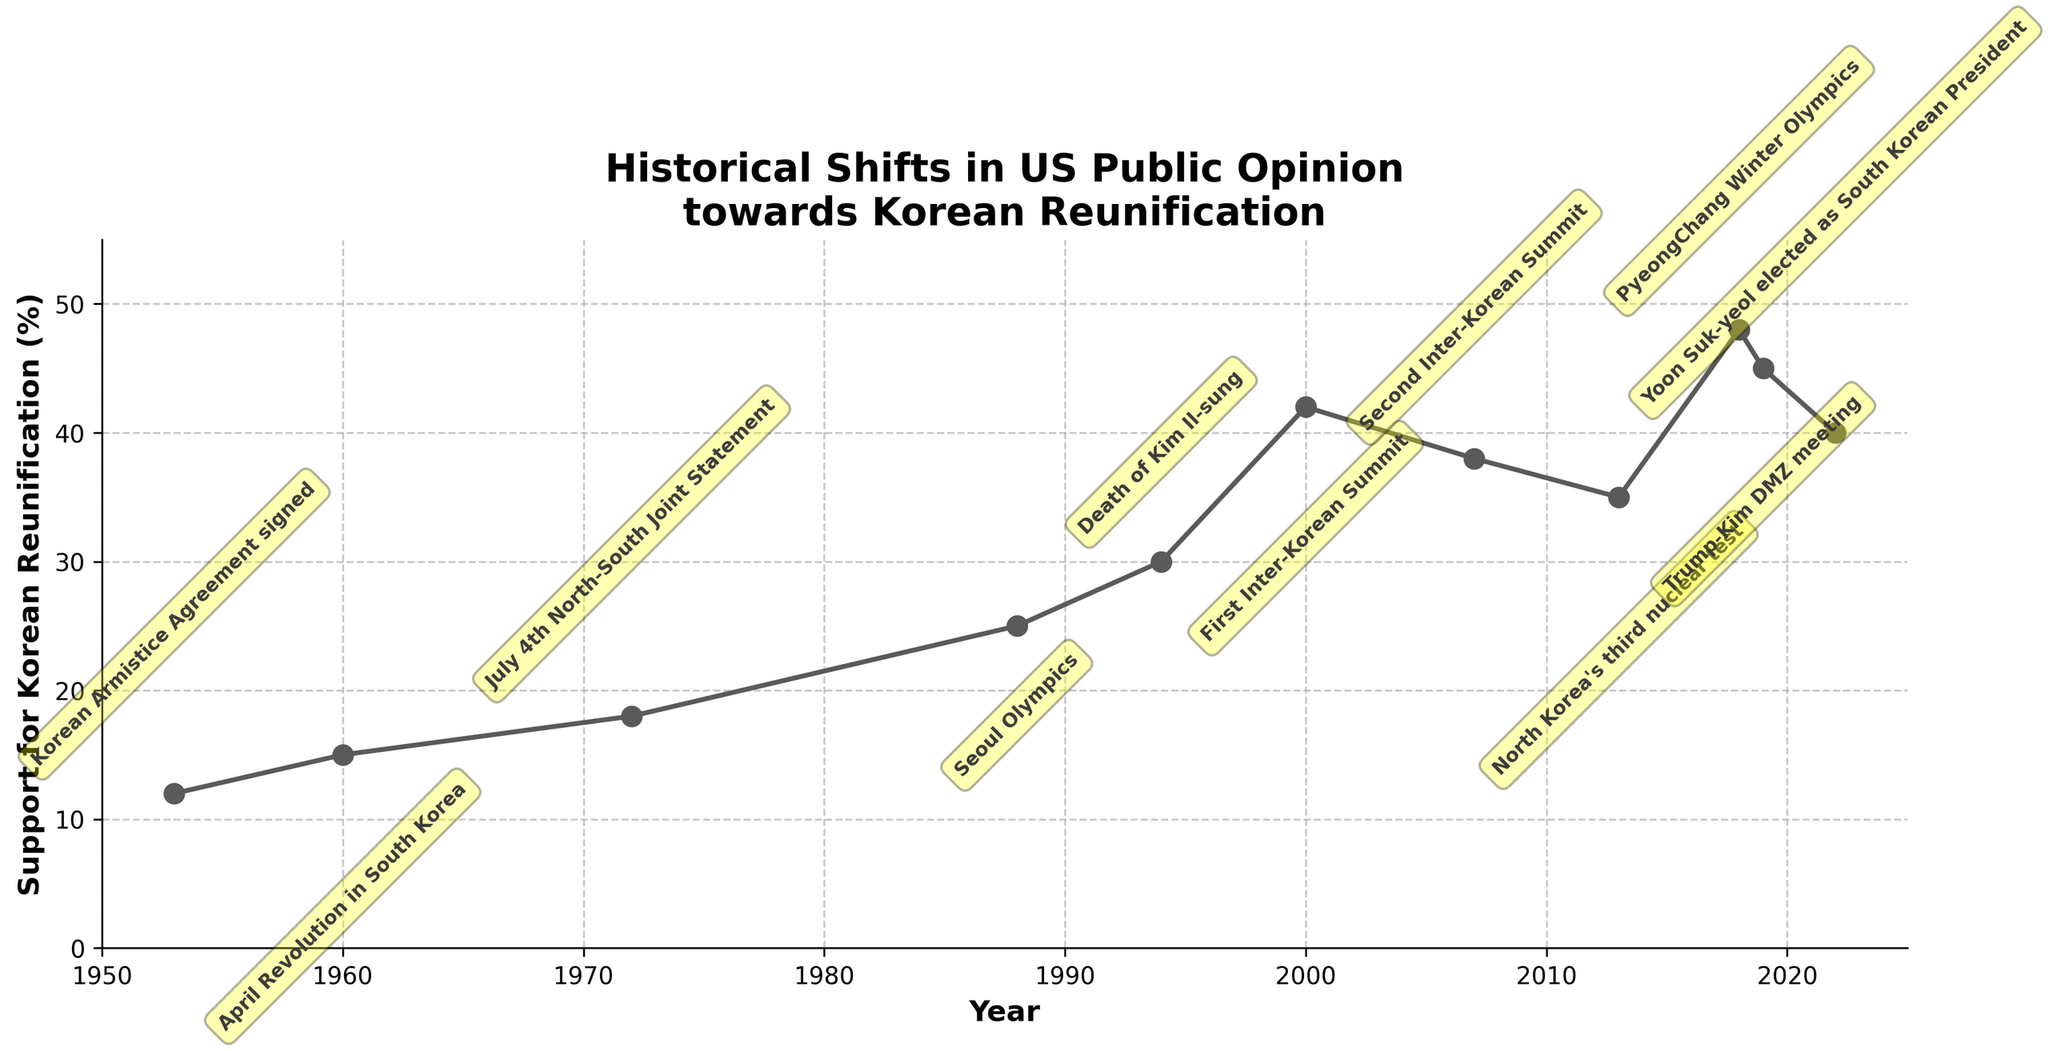How did the public opinion change immediately following the first Inter-Korean Summit in 2000? Look at the data points before and after the year 2000. Public support for Korean reunification increased from 30% in 1994 to 42% in 2000.
Answer: Increased Which year saw the highest support for Korean reunification and what was the percentage during that year? Look for the peak value in the plot. In 2018, support reached its highest at 48%.
Answer: 2018, 48% Compare the change in support between the years 1988 and 1994. Did the support increase or decrease and by how much? Review the values for these years. From 1988 (25%) to 1994 (30%), the support increased. The difference is 30% - 25% = 5%.
Answer: Increased by 5% How does the support in 2013 compare to that in 2007? Compare the data points for 2013 and 2007. In 2007, the support was 38%, and in 2013, it was 35%, implying a decrease.
Answer: Decreased What is the average support for Korean reunification for the years 1953, 1960, and 1972? Calculate the mean of the values from these years. (12% + 15% + 18%) / 3 = 15%.
Answer: 15% Identify two major events associated with an increase in public support for Korean reunification. Examine years with upward trends in support and associated events. The first Inter-Korean Summit in 2000 and the PyeongChang Winter Olympics in 2018 both saw increases.
Answer: First Inter-Korean Summit, PyeongChang Winter Olympics What trend was observed in public support for Korean reunification from 2000 to 2007? Compare the data points for 2000 and 2007. Support decreased from 42% in 2000 to 38% in 2007.
Answer: Decrease By what percentage did public support for Korean reunification change from the year 1994 to 2000? Calculate the percentage change: (42% - 30%) / 30% * 100% ≈ 40%.
Answer: 40% Did the death of Kim Il-sung in 1994 have a significant impact on public opinion in the following years? Compare the value before and after 1994 to identify if there's a noticeable change. Between 1988 and 1994, there was an increase of 5%.
Answer: Yes What was the difference in support before and after Yoon Suk-yeol was elected as South Korean President in 2022? Compare values for 2019 and 2022. In 2019, the support was 45%, and in 2022, it was 40%. The difference is 45% - 40% = 5%.
Answer: 5% decrease 